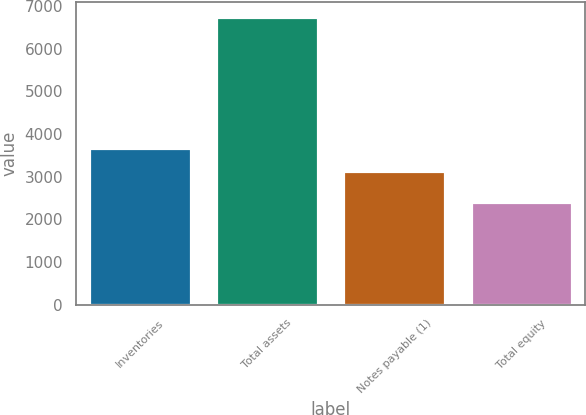Convert chart to OTSL. <chart><loc_0><loc_0><loc_500><loc_500><bar_chart><fcel>Inventories<fcel>Total assets<fcel>Notes payable (1)<fcel>Total equity<nl><fcel>3666.7<fcel>6756.8<fcel>3145.3<fcel>2400.6<nl></chart> 